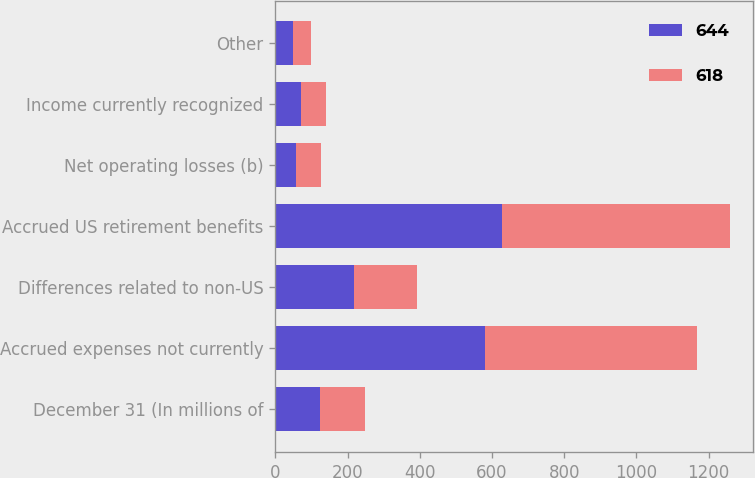<chart> <loc_0><loc_0><loc_500><loc_500><stacked_bar_chart><ecel><fcel>December 31 (In millions of<fcel>Accrued expenses not currently<fcel>Differences related to non-US<fcel>Accrued US retirement benefits<fcel>Net operating losses (b)<fcel>Income currently recognized<fcel>Other<nl><fcel>644<fcel>123.5<fcel>582<fcel>217<fcel>629<fcel>56<fcel>71<fcel>50<nl><fcel>618<fcel>123.5<fcel>586<fcel>176<fcel>630<fcel>70<fcel>70<fcel>49<nl></chart> 